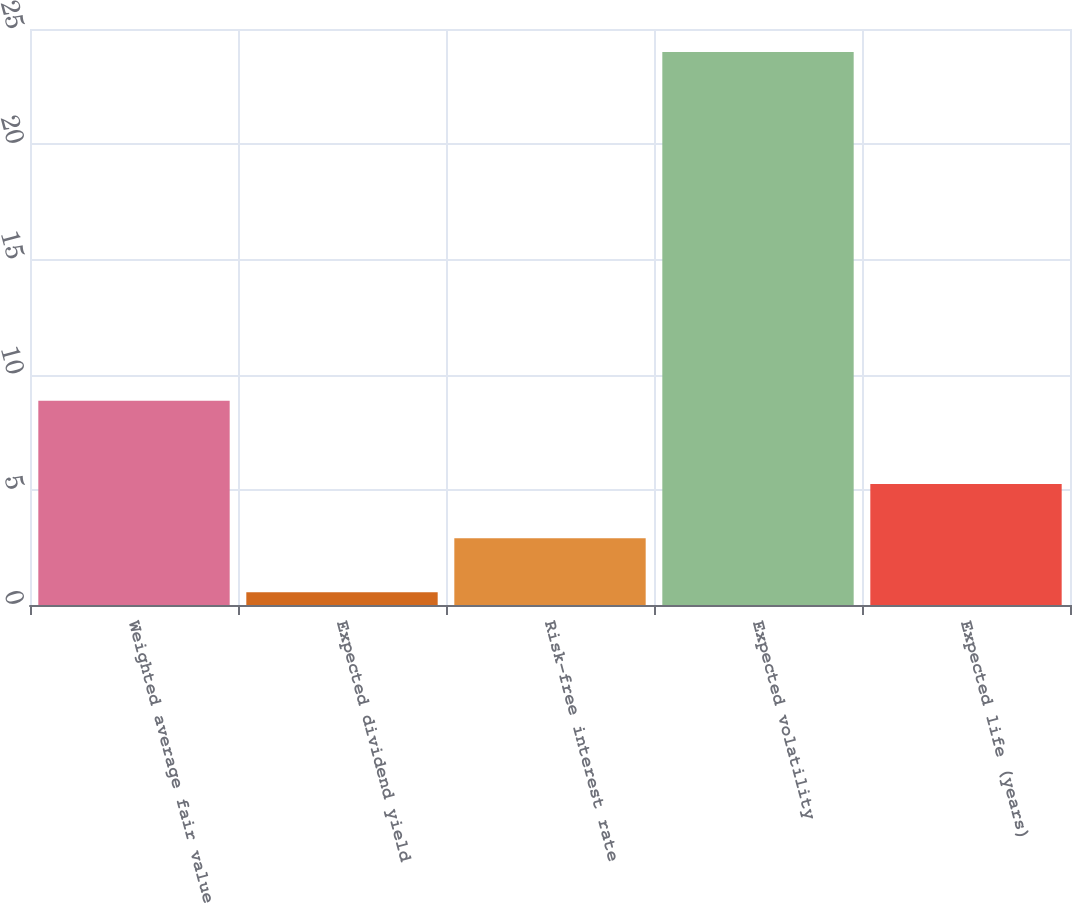Convert chart to OTSL. <chart><loc_0><loc_0><loc_500><loc_500><bar_chart><fcel>Weighted average fair value<fcel>Expected dividend yield<fcel>Risk-free interest rate<fcel>Expected volatility<fcel>Expected life (years)<nl><fcel>8.86<fcel>0.55<fcel>2.9<fcel>24<fcel>5.25<nl></chart> 